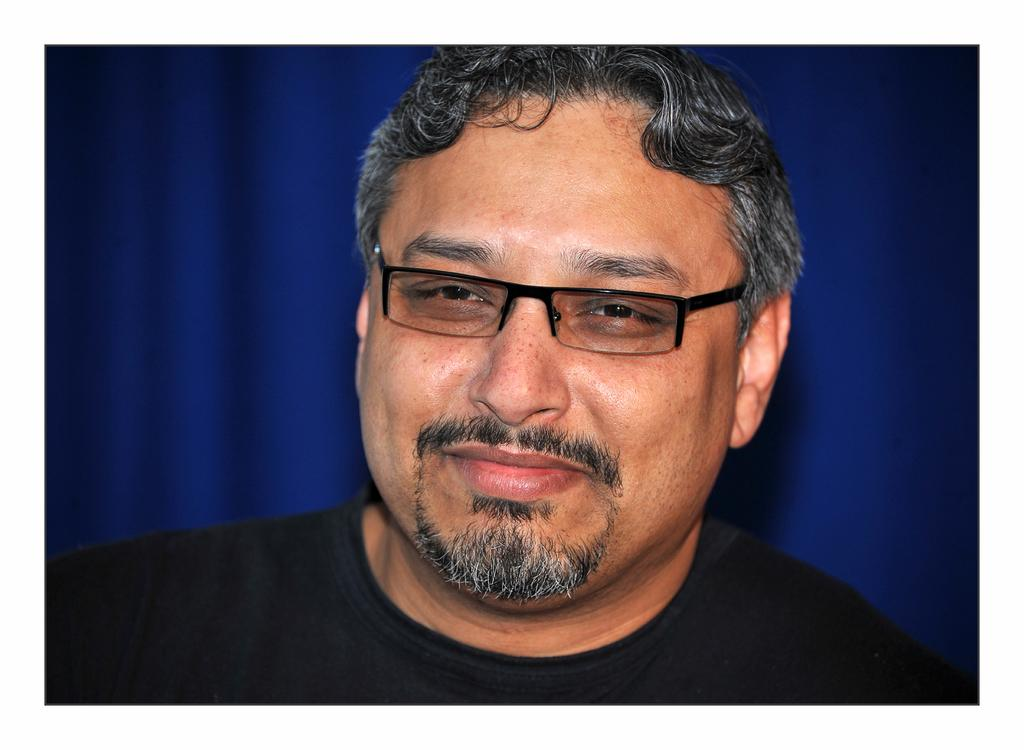Who or what is the main subject of the image? There is a person in the image. Can you describe the position of the person in the image? The person is in the middle of the image. What is the person wearing in the image? The person is wearing a black color t-shirt. What can be seen in the background of the image? There is a blue color wall in the background of the image. How does the person create smoke in the image? There is no smoke present in the image, and the person is not creating any. 